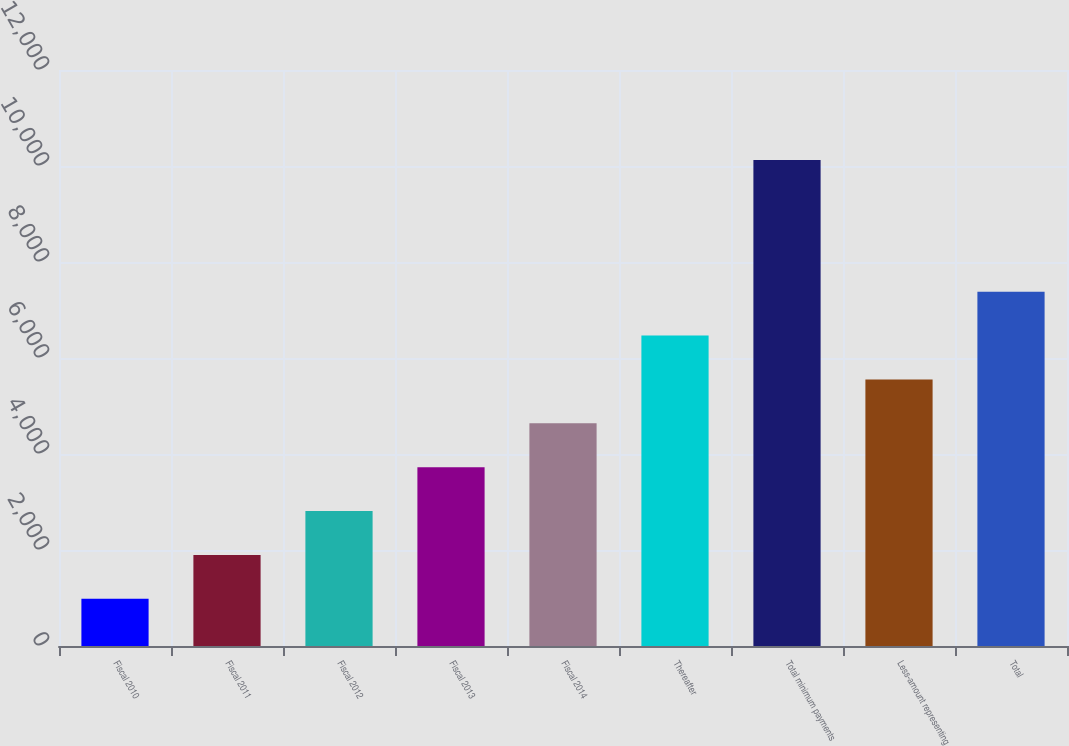Convert chart. <chart><loc_0><loc_0><loc_500><loc_500><bar_chart><fcel>Fiscal 2010<fcel>Fiscal 2011<fcel>Fiscal 2012<fcel>Fiscal 2013<fcel>Fiscal 2014<fcel>Thereafter<fcel>Total minimum payments<fcel>Less-amount representing<fcel>Total<nl><fcel>982<fcel>1896.1<fcel>2810.2<fcel>3724.3<fcel>4638.4<fcel>6466.6<fcel>10123<fcel>5552.5<fcel>7380.7<nl></chart> 